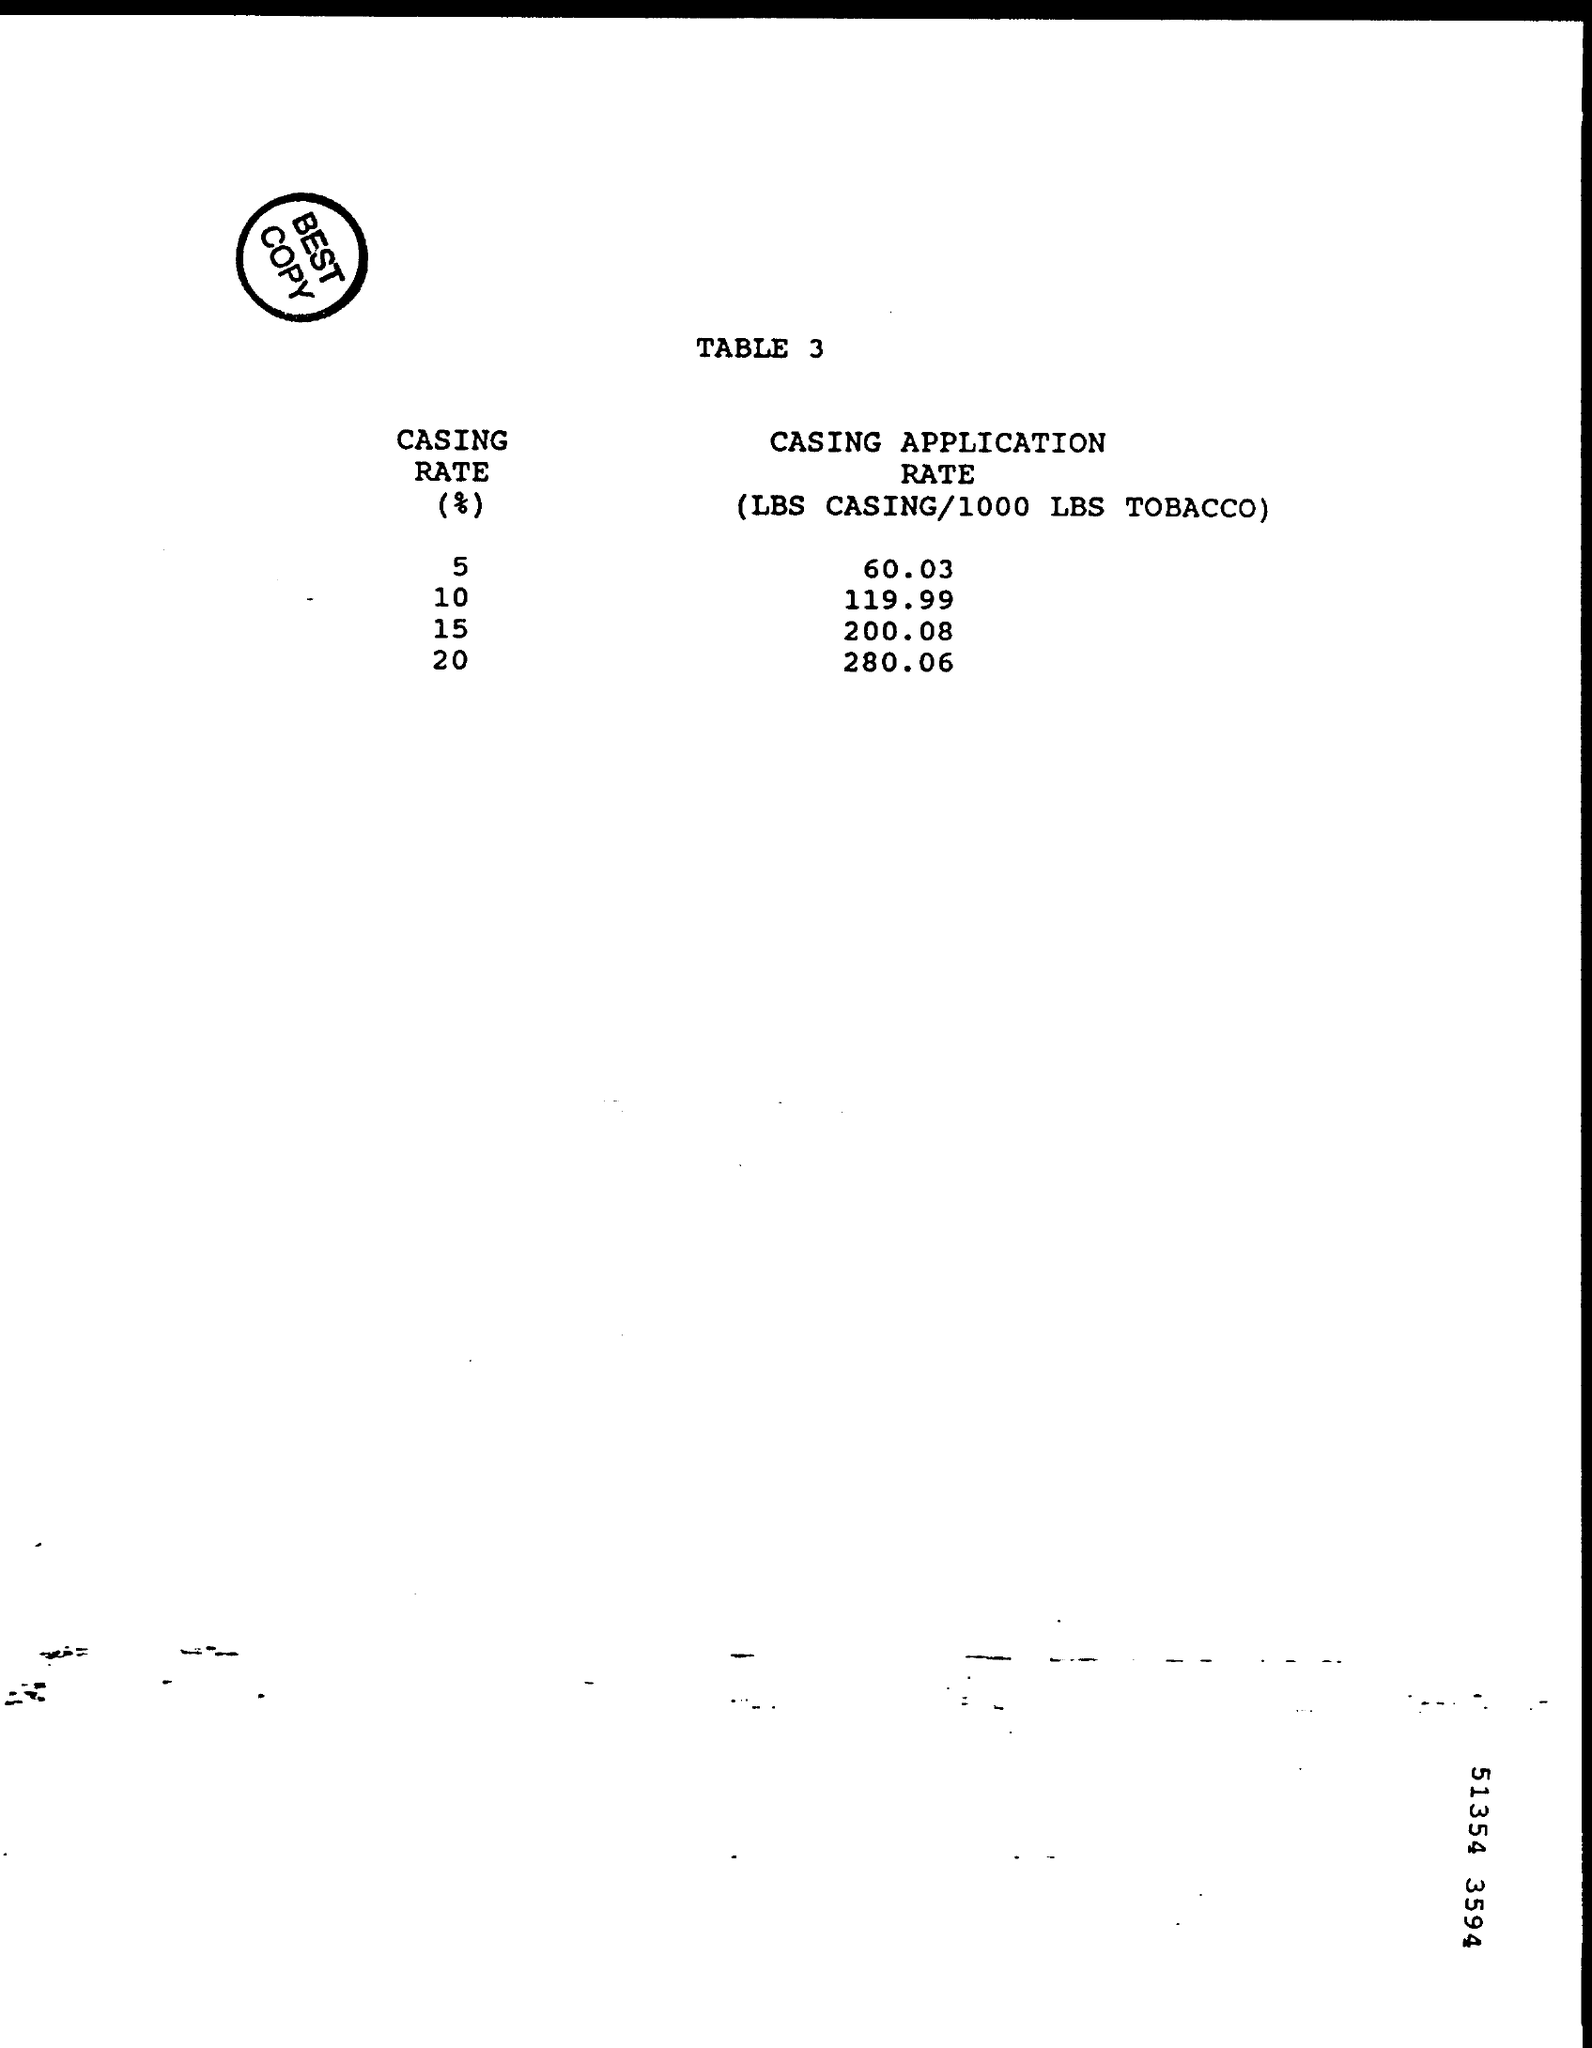Indicate a few pertinent items in this graphic. The text written inside the circle is considered the best. The heading of the document is "What is the heading of the document?" TABLE 3.. The casing rate for Casing Application 280.06 is 20... 